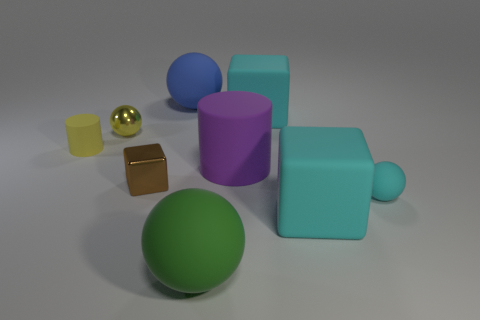Does the tiny cyan sphere have the same material as the tiny brown thing?
Keep it short and to the point. No. There is a object that is the same color as the tiny rubber cylinder; what is its shape?
Offer a very short reply. Sphere. Are there any small yellow cylinders?
Your response must be concise. Yes. There is a big thing to the left of the green thing; does it have the same shape as the small matte thing that is behind the tiny rubber ball?
Ensure brevity in your answer.  No. What number of tiny things are yellow rubber cylinders or purple rubber cylinders?
Ensure brevity in your answer.  1. There is a small yellow thing that is made of the same material as the green object; what shape is it?
Provide a short and direct response. Cylinder. Do the large blue object and the small cyan object have the same shape?
Ensure brevity in your answer.  Yes. What is the color of the tiny rubber sphere?
Offer a terse response. Cyan. How many things are tiny yellow things or small matte blocks?
Offer a terse response. 2. Are there fewer shiny things that are behind the tiny yellow cylinder than green metallic cubes?
Provide a succinct answer. No. 